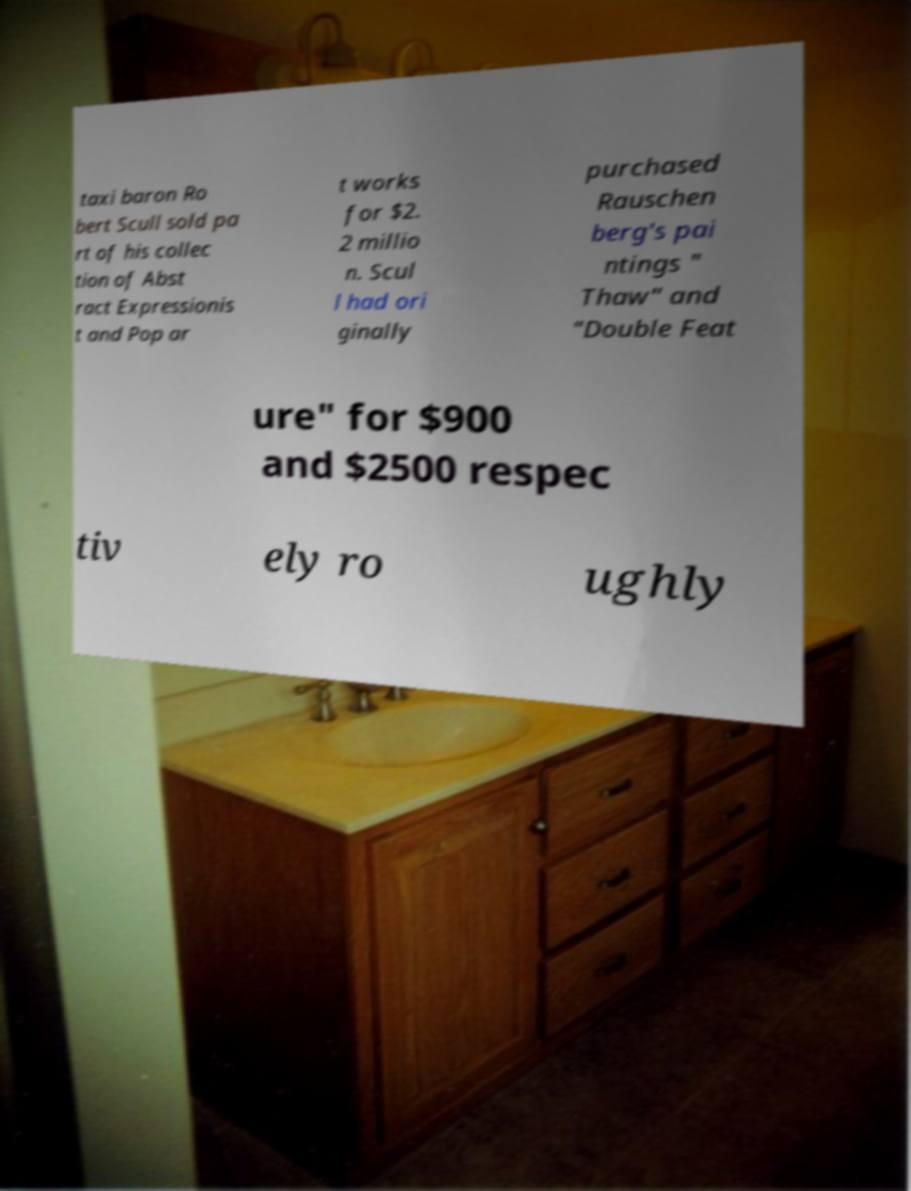I need the written content from this picture converted into text. Can you do that? taxi baron Ro bert Scull sold pa rt of his collec tion of Abst ract Expressionis t and Pop ar t works for $2. 2 millio n. Scul l had ori ginally purchased Rauschen berg's pai ntings " Thaw" and "Double Feat ure" for $900 and $2500 respec tiv ely ro ughly 